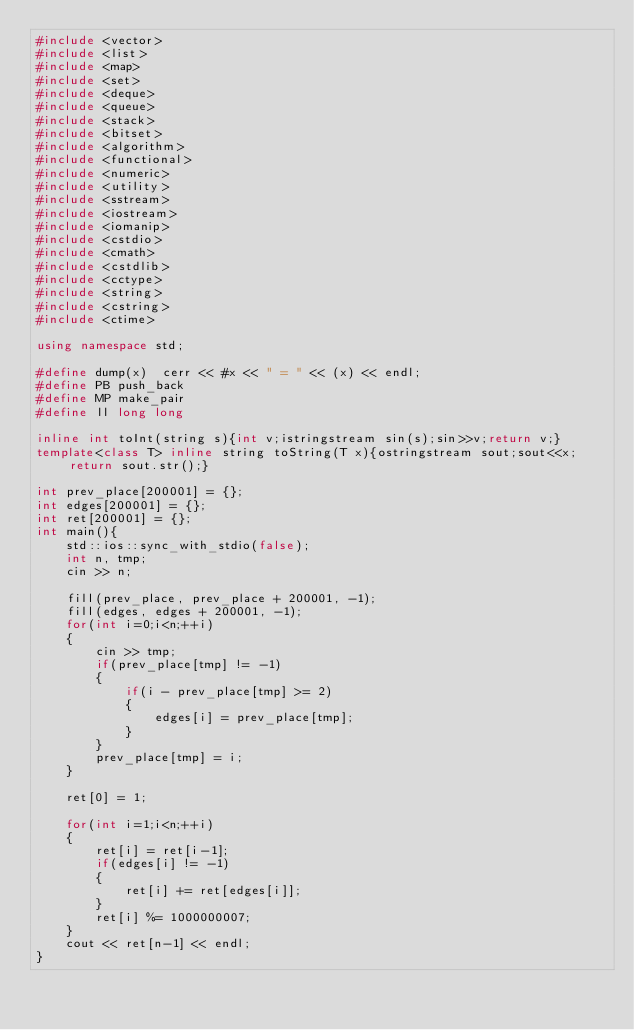<code> <loc_0><loc_0><loc_500><loc_500><_C++_>#include <vector>
#include <list>
#include <map>
#include <set>
#include <deque>
#include <queue>
#include <stack>
#include <bitset>
#include <algorithm>
#include <functional>
#include <numeric>
#include <utility>
#include <sstream>
#include <iostream>
#include <iomanip>
#include <cstdio>
#include <cmath>
#include <cstdlib>
#include <cctype>
#include <string>
#include <cstring>
#include <ctime>

using namespace std;

#define dump(x)  cerr << #x << " = " << (x) << endl;
#define PB push_back
#define MP make_pair
#define ll long long

inline int toInt(string s){int v;istringstream sin(s);sin>>v;return v;}
template<class T> inline string toString(T x){ostringstream sout;sout<<x;return sout.str();}

int prev_place[200001] = {};
int edges[200001] = {};
int ret[200001] = {};
int main(){
    std::ios::sync_with_stdio(false);
    int n, tmp;
    cin >> n;

    fill(prev_place, prev_place + 200001, -1);
    fill(edges, edges + 200001, -1);
    for(int i=0;i<n;++i)
    {
        cin >> tmp;
        if(prev_place[tmp] != -1)
        {
            if(i - prev_place[tmp] >= 2)
            {
                edges[i] = prev_place[tmp];
            }
        }
        prev_place[tmp] = i;        
    }
    
    ret[0] = 1;

    for(int i=1;i<n;++i)
    {
        ret[i] = ret[i-1];
        if(edges[i] != -1)
        {
            ret[i] += ret[edges[i]];
        }
        ret[i] %= 1000000007;
    }
    cout << ret[n-1] << endl;
}</code> 